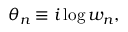Convert formula to latex. <formula><loc_0><loc_0><loc_500><loc_500>\theta _ { n } \equiv i \log { w _ { n } } ,</formula> 